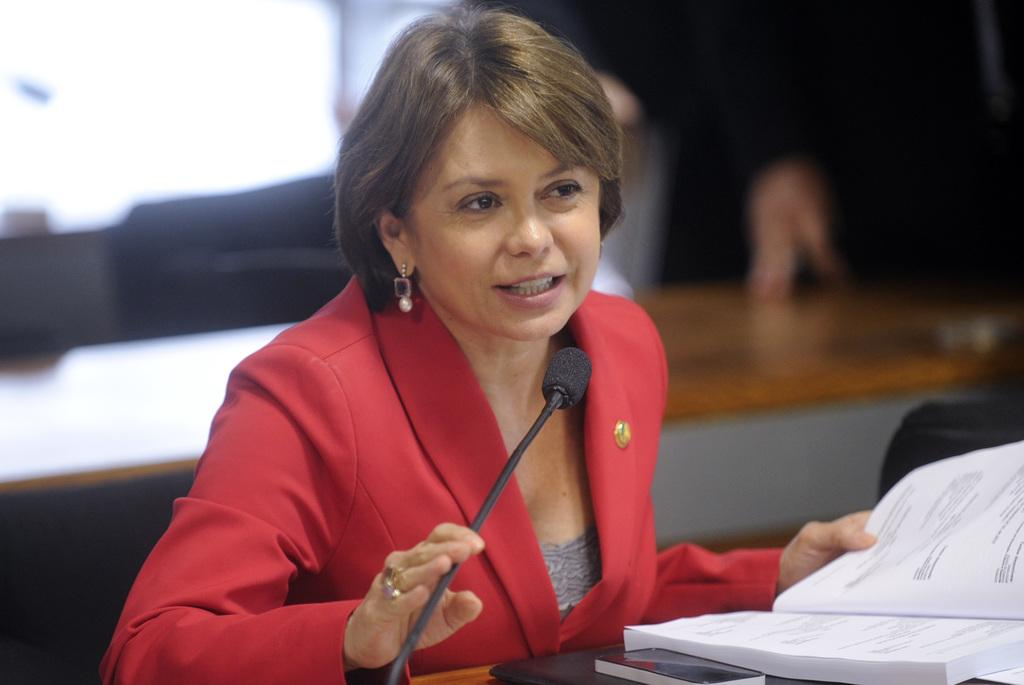What can be seen in the image? There is a person in the image. What is the person wearing? The person is wearing a red and ash color dress. What is in front of the person? There is a book, mice, and an unspecified object in front of the person. Can you describe the background of the image? The background of the image is blurred. What type of gun can be seen in the person's hand in the image? There is no gun present in the image; the person is not holding any object in their hand. 